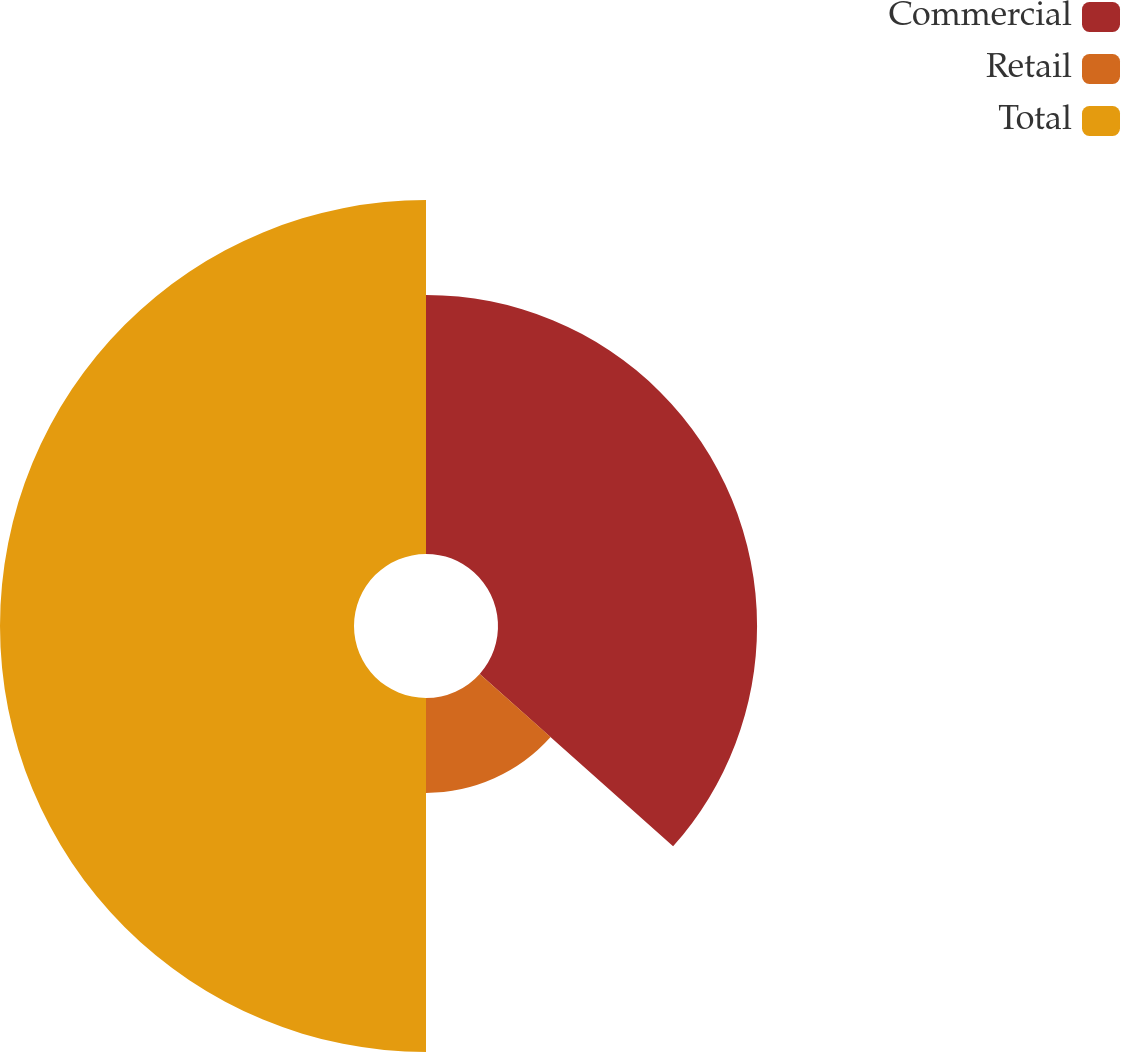<chart> <loc_0><loc_0><loc_500><loc_500><pie_chart><fcel>Commercial<fcel>Retail<fcel>Total<nl><fcel>36.59%<fcel>13.41%<fcel>50.0%<nl></chart> 